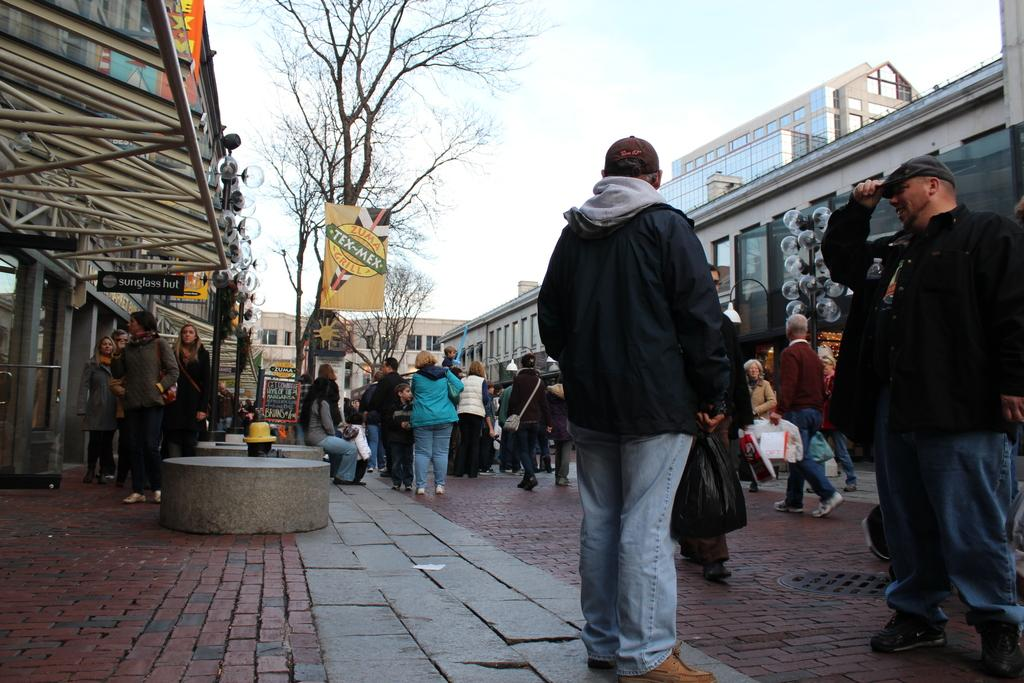What can be seen in the image in terms of people? There are groups of people in the image. What is the purpose of the banner in the image? The purpose of the banner cannot be determined from the image alone. What type of vegetation is present in the image? There are trees in the image. What decorative items can be seen in the image? Balloons are present in the image. What type of structures are visible in the image? There are buildings in the image. What is visible in the background of the image? The sky is visible in the image. Can you tell me how many sisters are present in the image? There is no mention of a sister or any individuals in the image, so it is impossible to determine the number of sisters present. What type of offer is being made by the people in the image? There is no indication of any offer being made in the image, as it only shows groups of people, a banner, trees, balloons, buildings, and the sky. 